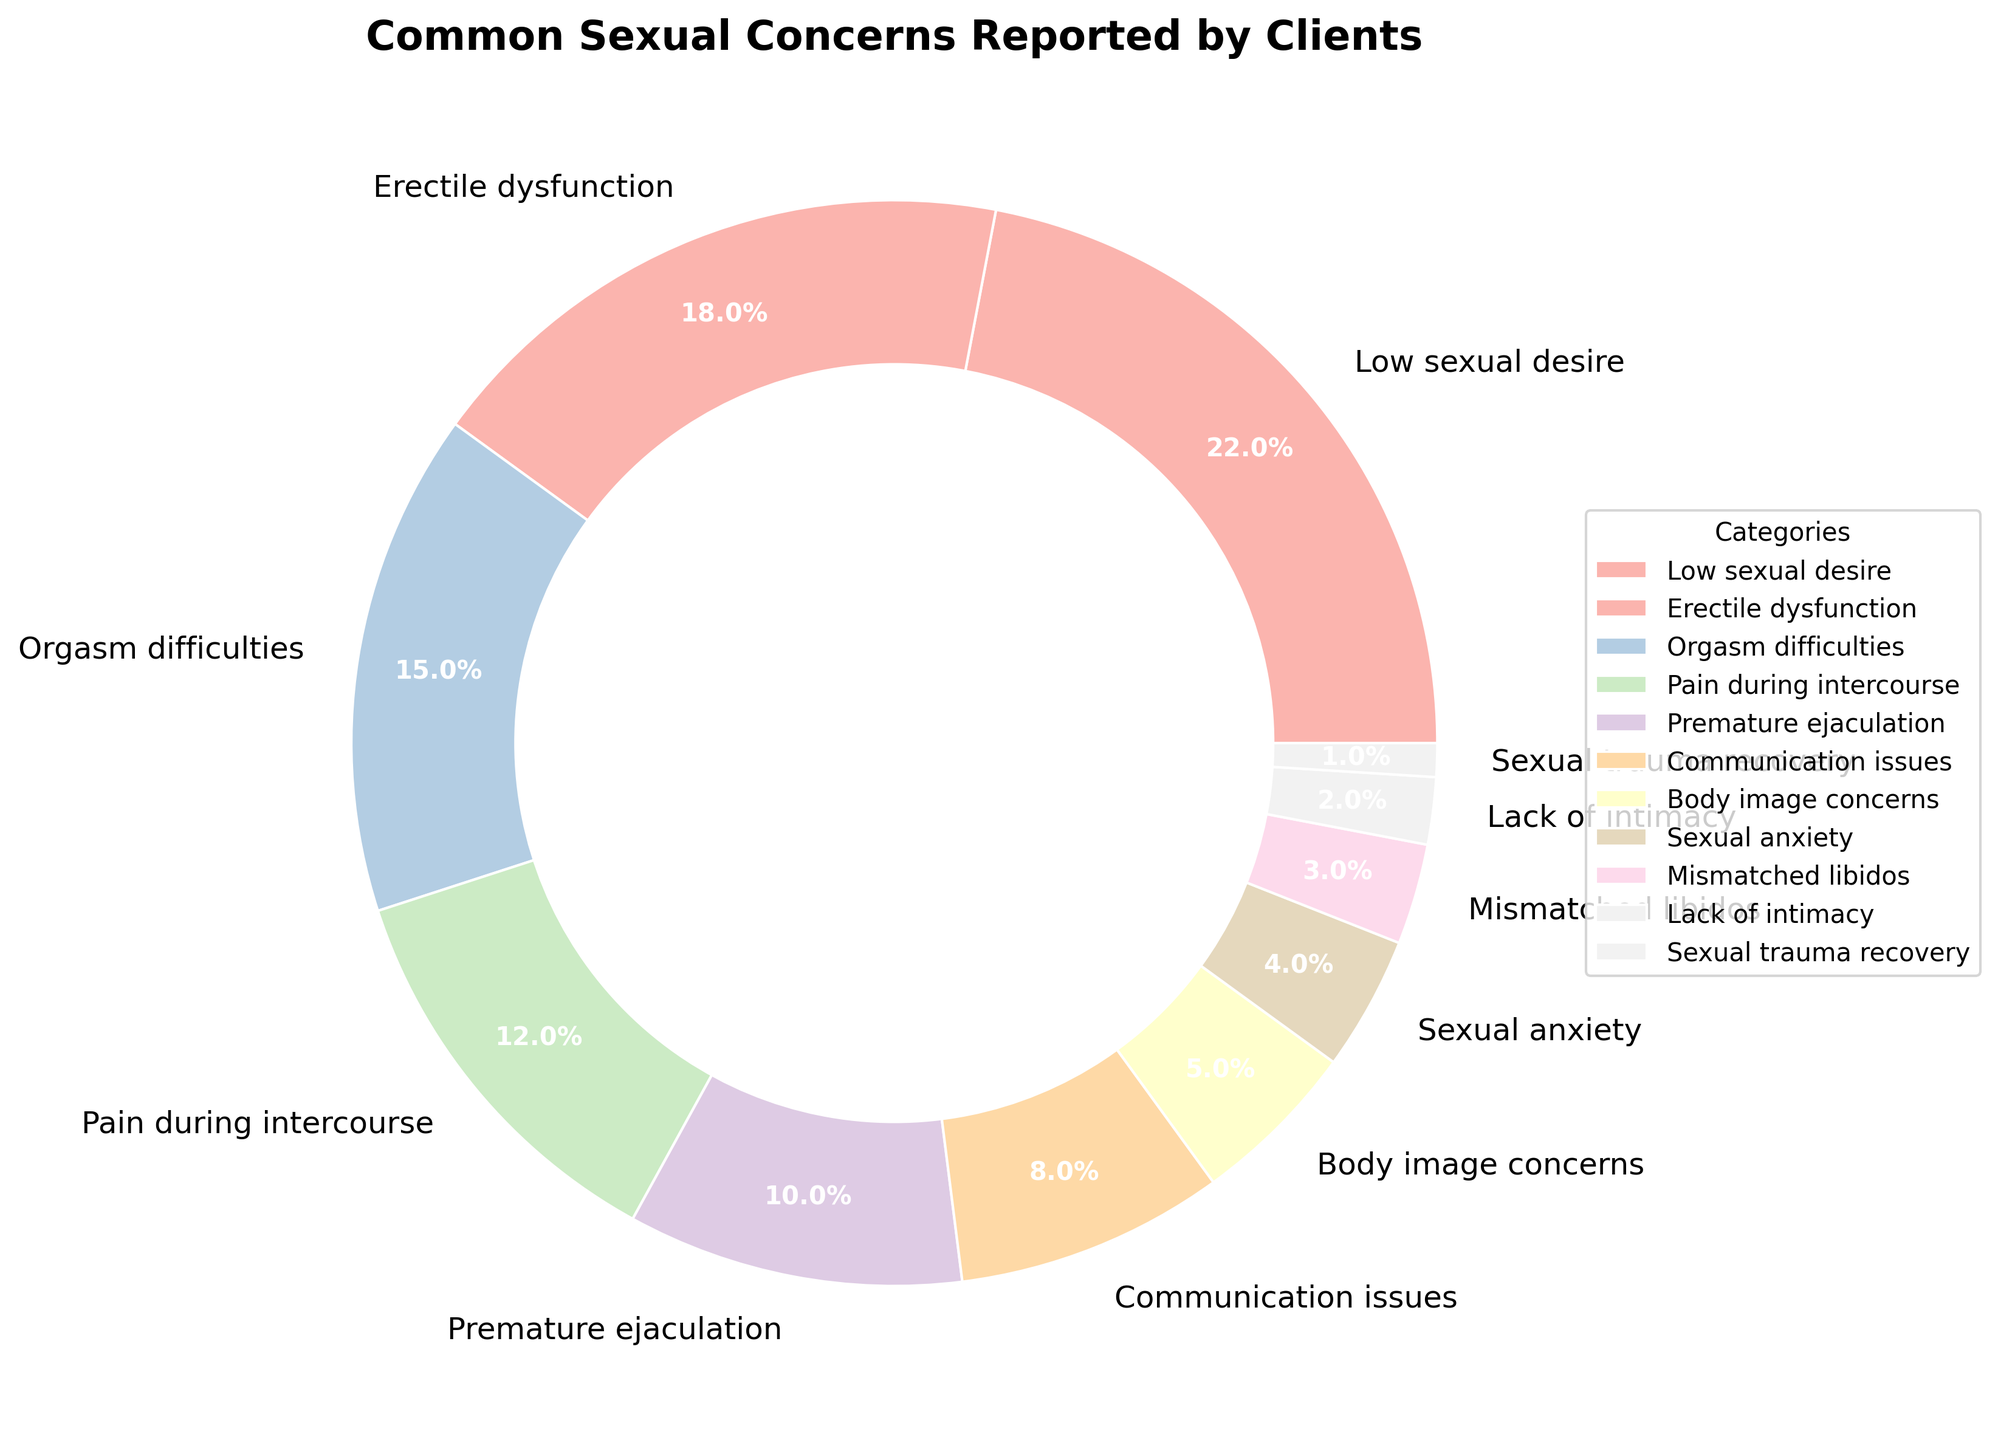What are the two most commonly reported sexual concerns by clients? The two largest sections in the pie chart represent the most commonly reported sexual concerns. Look for the two categories with the highest percentages.
Answer: Low sexual desire and Erectile dysfunction Which sexual concern is reported the least by clients? Identify the smallest section in the pie chart.
Answer: Sexual trauma recovery Combine the percentages of concerns related to communication and body image. What is the total percentage? Add the percentages of Communication issues (8%) and Body image concerns (5%).
Answer: 13% Is the percentage of clients reporting pain during intercourse greater than those reporting premature ejaculation? Compare the size (percentage) of "Pain during intercourse" (12%) with that of "Premature ejaculation" (10%).
Answer: Yes Which has a bigger percentage: Orgasm difficulties or Premature ejaculation? Compare the percentages of Orgasm difficulties (15%) and Premature ejaculation (10%).
Answer: Orgasm difficulties How many types of concerns have a percentage of at least 10%? Count those categories with percentages of 10% or more.
Answer: 5 What is the combined percentage of clients reporting Sexual anxiety and Mismatched libidos? Add the percentages of Sexual anxiety (4%) and Mismatched libidos (3%).
Answer: 7% Compare Low sexual desire and Erectile dysfunction. What is the difference in their percentages? Subtract the percentage of Erectile dysfunction (18%) from that of Low sexual desire (22%).
Answer: 4% What's the combined percentage of all concerns smaller than 5%? Add the percentages of Sexual anxiety (4%), Mismatched libidos (3%), Lack of intimacy (2%), and Sexual trauma recovery (1%).
Answer: 10% How does the percentage of clients reporting Body image concerns compare to those reporting Communication issues? Compare the percentages of Body image concerns (5%) and Communication issues (8%).
Answer: Less 